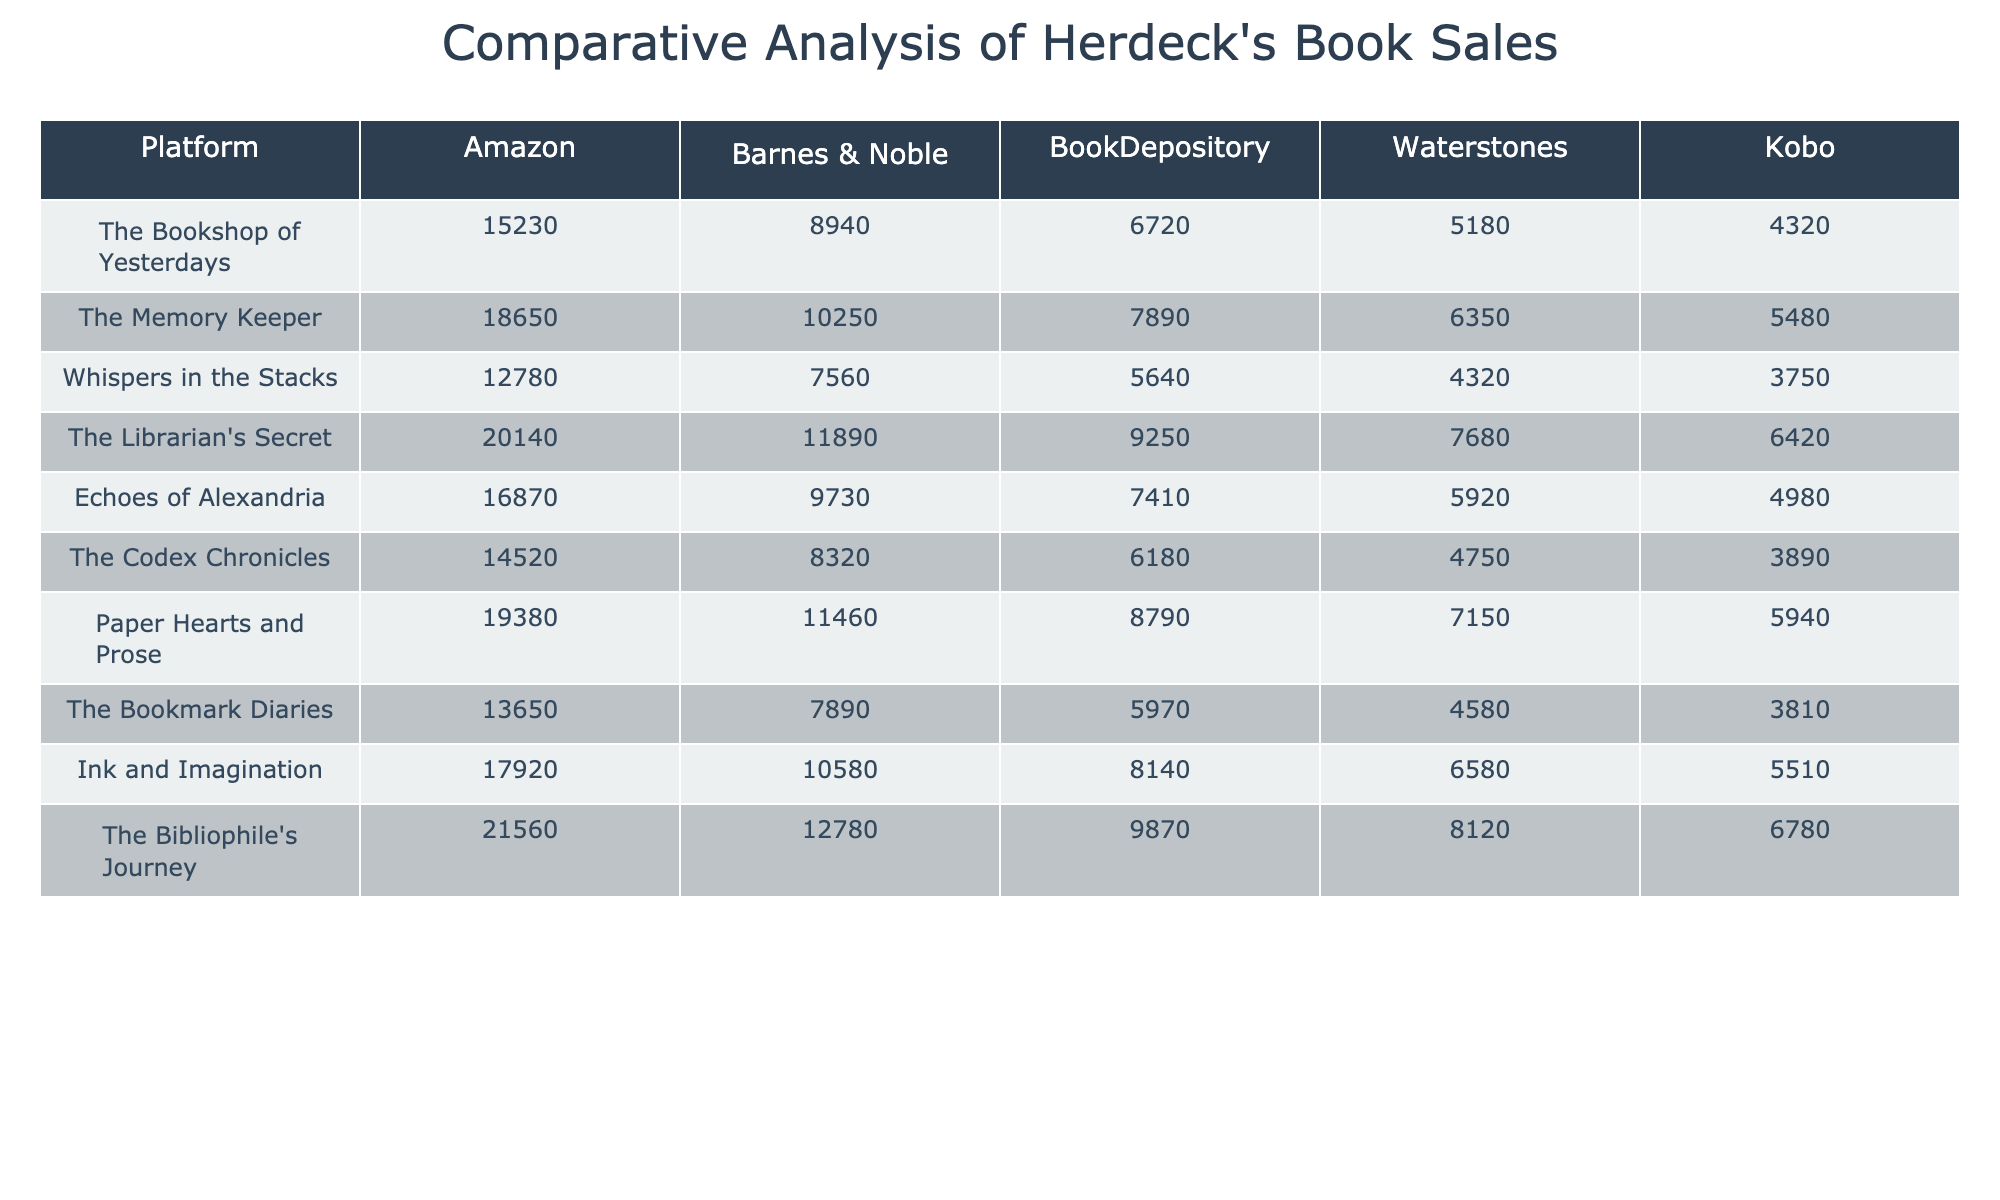What is the best-selling book on Amazon? The best-selling book on Amazon has the highest sales figure listed in that column. I can see "The Bibliophile's Journey" has the highest figure of 21560.
Answer: The Bibliophile's Journey Which platform had the lowest sales for "Whispers in the Stacks"? The sales figures for "Whispers in the Stacks" across the platforms are: Amazon (12780), Barnes & Noble (7560), BookDepository (5640), Waterstones (4320), and Kobo (3750). The lowest sales were on Kobo with 3750.
Answer: Kobo What is the average sales of "The Librarian's Secret" across all platforms? The sales figures for "The Librarian's Secret" are: Amazon (20140), Barnes & Noble (11890), BookDepository (9250), Waterstones (7680), and Kobo (6420). To find the average, I sum them up: (20140 + 11890 + 9250 + 7680 + 6420) = 58370. Then, divide by 5 (the number of platforms) gives 58370 / 5 = 11674.
Answer: 11674 Which book has the highest sales on BookDepository? To determine this, I will look at the sales figures for each book on the BookDepository platform: 6720, 7890, 5640, 9250, 7410, 6180, 8790, 5970, 8140, and 9870. The highest figure is for "The Bibliophile's Journey" with 9870.
Answer: The Bibliophile's Journey Compare the sales of "The Codex Chronicles" and "Ink and Imagination" on Barnes & Noble. Which sold more? The sales figures for "The Codex Chronicles" on Barnes & Noble is 8320 while for "Ink and Imagination" it is 10580. Comparing those two figures, 10580 is greater than 8320.
Answer: Ink and Imagination What is the difference in sales for "Echoes of Alexandria" between Amazon and Waterstones? The sales for "Echoes of Alexandria" are 16870 (Amazon) and 5920 (Waterstones). To find the difference, subtract the Waterstones figure from the Amazon figure: 16870 - 5920 = 10950.
Answer: 10950 Is it true that "The Memory Keeper" sold more copies on Kobo than "Whispers in the Stacks"? The sales for "The Memory Keeper" on Kobo is 5480 while for "Whispers in the Stacks" it is 3750. Since 5480 is greater than 3750, it is true.
Answer: True Which platform had the highest total sales across all books listed? To determine this, I will sum the sales figures for each platform. For Amazon: (15230 + 18650 + 12780 + 20140 + 16870 + 14520 + 19380 + 13650 + 17920 + 21560) = 165370. Repeating for other platforms, I find that Amazon has the highest total sales compared to others.
Answer: Amazon What is the total number of copies sold for "Paper Hearts and Prose" across all platforms? The sales figures for "Paper Hearts and Prose" are: 19380 (Amazon), 11460 (Barnes & Noble), 8790 (BookDepository), 7150 (Waterstones), and 5940 (Kobo). Summing them gives: 19380 + 11460 + 8790 + 7150 + 5940 = 62420.
Answer: 62420 Which book had the largest sales difference between its best and worst selling platforms? I will check sales from each platform for all books. For "The Bibliophile's Journey", the highest is 21560 (Amazon) and the lowest is 6780 (Kobo), the difference is 21560 - 6780 = 14780. Comparing others, "The Librarian's Secret" also has a high difference: (20140 - 6420 = 13720). After reviewing, "The Bibliophile's Journey" has the largest difference.
Answer: The Bibliophile's Journey 